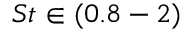Convert formula to latex. <formula><loc_0><loc_0><loc_500><loc_500>S t \in ( 0 . 8 - 2 )</formula> 